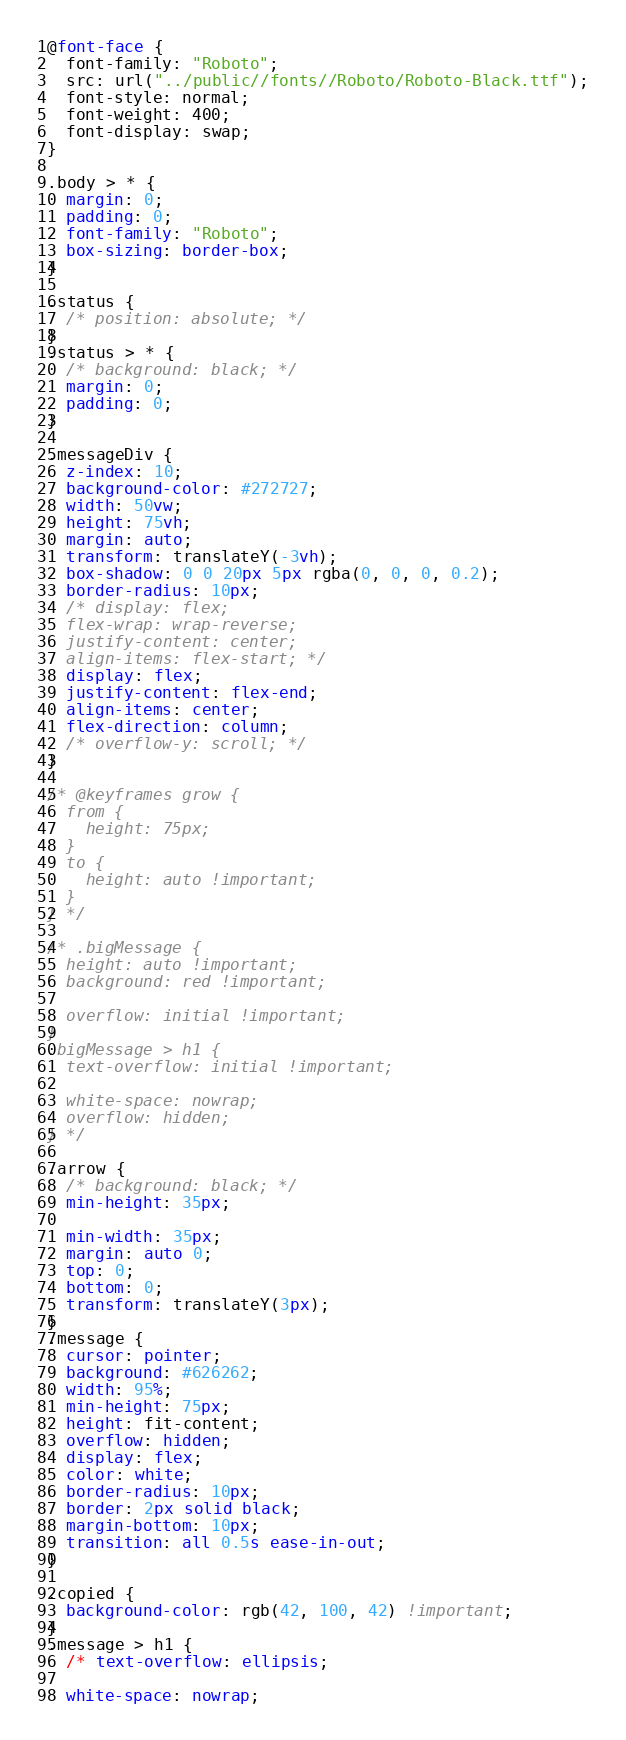<code> <loc_0><loc_0><loc_500><loc_500><_CSS_>@font-face {
  font-family: "Roboto";
  src: url("../public//fonts//Roboto/Roboto-Black.ttf");
  font-style: normal;
  font-weight: 400;
  font-display: swap;
}

.body > * {
  margin: 0;
  padding: 0;
  font-family: "Roboto";
  box-sizing: border-box;
}

.status {
  /* position: absolute; */
}
.status > * {
  /* background: black; */
  margin: 0;
  padding: 0;
}

.messageDiv {
  z-index: 10;
  background-color: #272727;
  width: 50vw;
  height: 75vh;
  margin: auto;
  transform: translateY(-3vh);
  box-shadow: 0 0 20px 5px rgba(0, 0, 0, 0.2);
  border-radius: 10px;
  /* display: flex;
  flex-wrap: wrap-reverse;
  justify-content: center;
  align-items: flex-start; */
  display: flex;
  justify-content: flex-end;
  align-items: center;
  flex-direction: column;
  /* overflow-y: scroll; */
}

/* @keyframes grow {
  from {
    height: 75px;
  }
  to {
    height: auto !important;
  }
} */

/* .bigMessage {
  height: auto !important;
  background: red !important;

  overflow: initial !important;
}
.bigMessage > h1 {
  text-overflow: initial !important;

  white-space: nowrap;
  overflow: hidden;
} */

.arrow {
  /* background: black; */
  min-height: 35px;

  min-width: 35px;
  margin: auto 0;
  top: 0;
  bottom: 0;
  transform: translateY(3px);
}
.message {
  cursor: pointer;
  background: #626262;
  width: 95%;
  min-height: 75px;
  height: fit-content;
  overflow: hidden;
  display: flex;
  color: white;
  border-radius: 10px;
  border: 2px solid black;
  margin-bottom: 10px;
  transition: all 0.5s ease-in-out;
}

.copied {
  background-color: rgb(42, 100, 42) !important;
}
.message > h1 {
  /* text-overflow: ellipsis;

  white-space: nowrap;</code> 